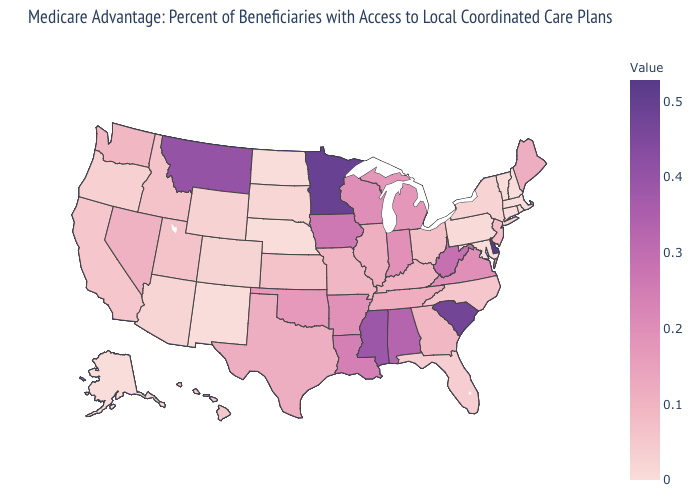Which states have the highest value in the USA?
Give a very brief answer. Delaware. Among the states that border Florida , does Alabama have the highest value?
Write a very short answer. Yes. Does the map have missing data?
Quick response, please. No. Does the map have missing data?
Answer briefly. No. Does Michigan have the highest value in the MidWest?
Quick response, please. No. 